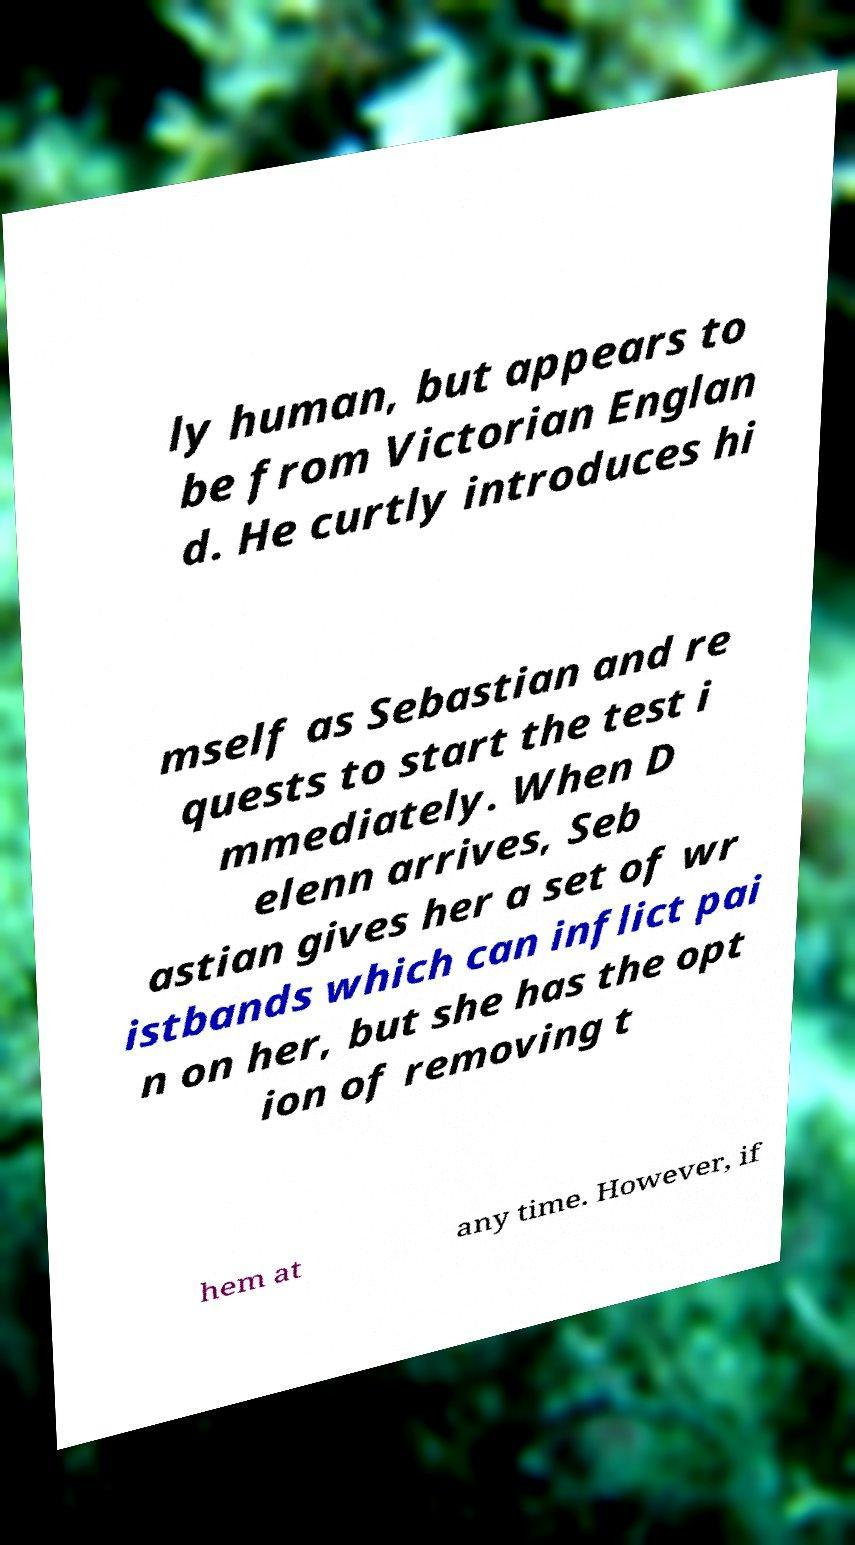Please identify and transcribe the text found in this image. ly human, but appears to be from Victorian Englan d. He curtly introduces hi mself as Sebastian and re quests to start the test i mmediately. When D elenn arrives, Seb astian gives her a set of wr istbands which can inflict pai n on her, but she has the opt ion of removing t hem at any time. However, if 